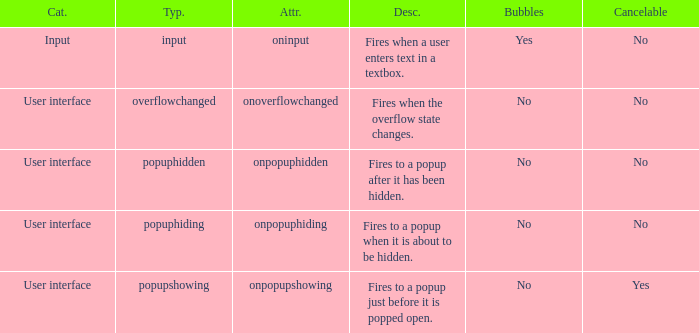 how many bubbles with category being input 1.0. 